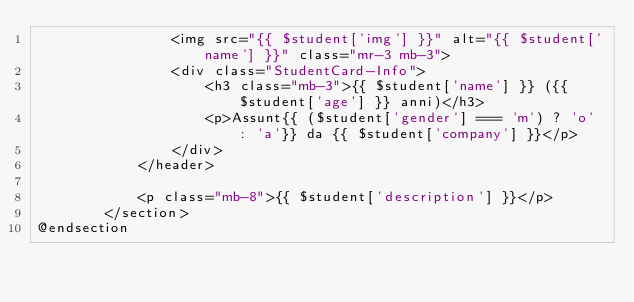<code> <loc_0><loc_0><loc_500><loc_500><_PHP_>                <img src="{{ $student['img'] }}" alt="{{ $student['name'] }}" class="mr-3 mb-3">
                <div class="StudentCard-Info">
                    <h3 class="mb-3">{{ $student['name'] }} ({{ $student['age'] }} anni)</h3>
                    <p>Assunt{{ ($student['gender'] === 'm') ? 'o' : 'a'}} da {{ $student['company'] }}</p>
                </div>
            </header>
                
            <p class="mb-8">{{ $student['description'] }}</p>
        </section>
@endsection</code> 